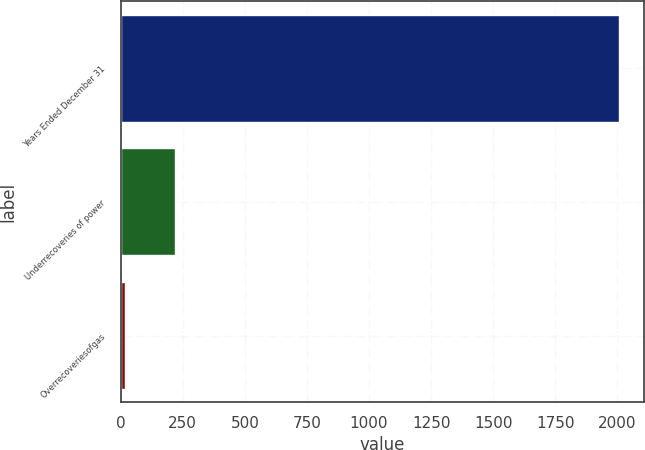Convert chart to OTSL. <chart><loc_0><loc_0><loc_500><loc_500><bar_chart><fcel>Years Ended December 31<fcel>Underrecoveries of power<fcel>Overrecoveriesofgas<nl><fcel>2007<fcel>217.8<fcel>19<nl></chart> 